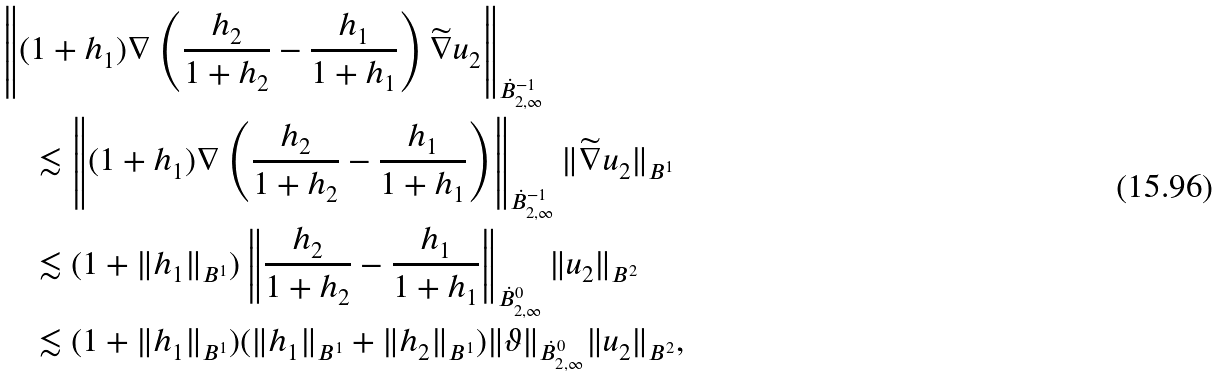<formula> <loc_0><loc_0><loc_500><loc_500>& \left \| ( 1 + h _ { 1 } ) \nabla \left ( \frac { h _ { 2 } } { 1 + h _ { 2 } } - \frac { h _ { 1 } } { 1 + h _ { 1 } } \right ) \widetilde { \nabla } u _ { 2 } \right \| _ { \dot { B } ^ { - 1 } _ { 2 , \infty } } \\ & \quad \lesssim \left \| ( 1 + h _ { 1 } ) \nabla \left ( \frac { h _ { 2 } } { 1 + h _ { 2 } } - \frac { h _ { 1 } } { 1 + h _ { 1 } } \right ) \right \| _ { \dot { B } ^ { - 1 } _ { 2 , \infty } } \| \widetilde { \nabla } u _ { 2 } \| _ { B ^ { 1 } } \\ & \quad \lesssim ( 1 + \| h _ { 1 } \| _ { B ^ { 1 } } ) \left \| \frac { h _ { 2 } } { 1 + h _ { 2 } } - \frac { h _ { 1 } } { 1 + h _ { 1 } } \right \| _ { \dot { B } ^ { 0 } _ { 2 , \infty } } \| u _ { 2 } \| _ { B ^ { 2 } } \\ & \quad \lesssim ( 1 + \| h _ { 1 } \| _ { B ^ { 1 } } ) ( \| h _ { 1 } \| _ { B ^ { 1 } } + \| h _ { 2 } \| _ { B ^ { 1 } } ) \| \vartheta \| _ { \dot { B } ^ { 0 } _ { 2 , \infty } } \| u _ { 2 } \| _ { B ^ { 2 } } ,</formula> 